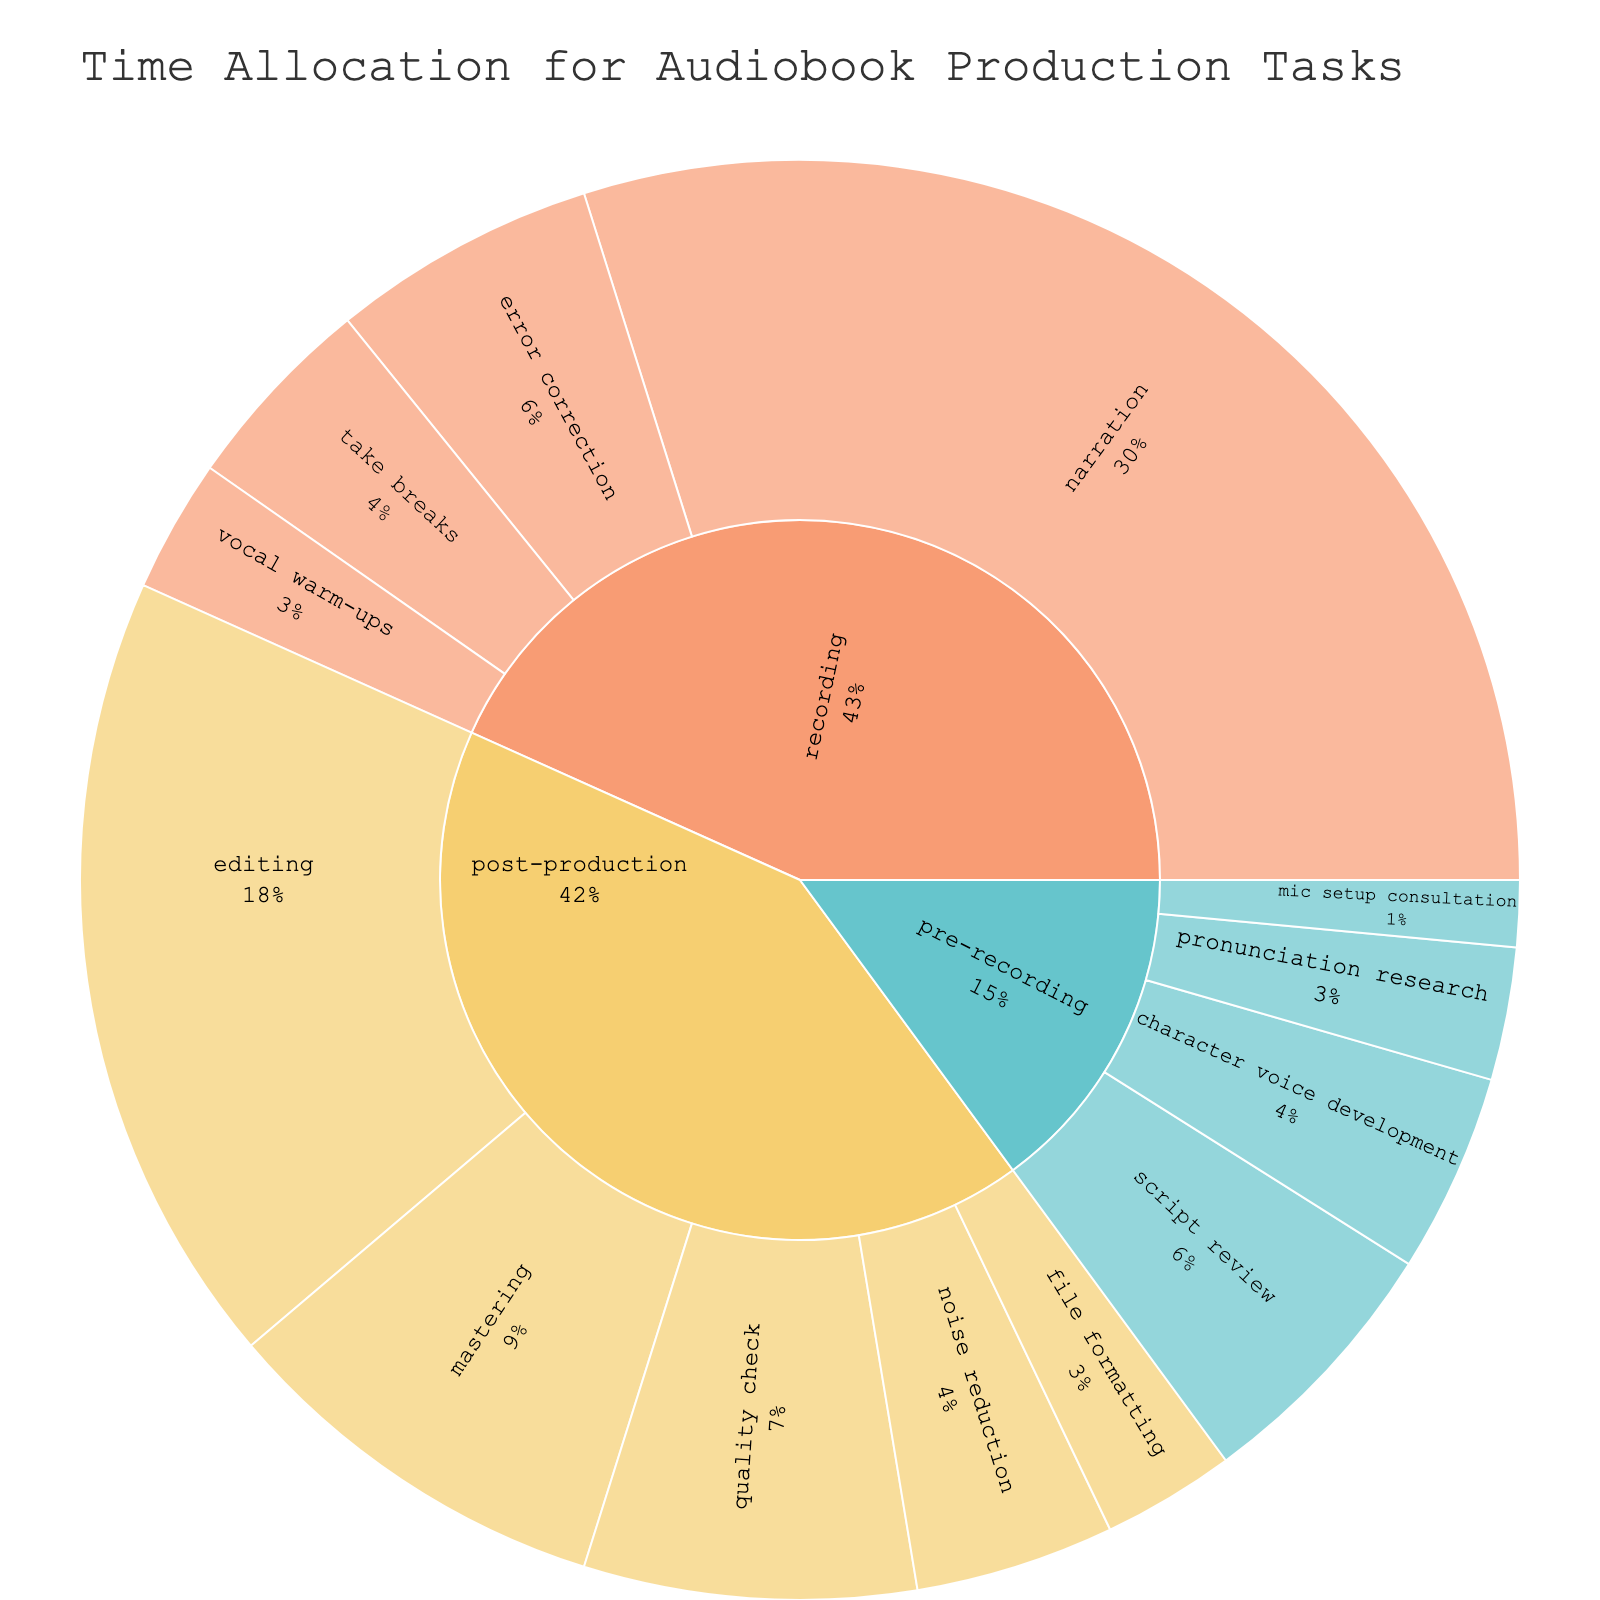What's the title of the figure? The title is usually placed at the top and gives an overview of the figure. Here, the title is "Time Allocation for Audiobook Production Tasks".
Answer: Time Allocation for Audiobook Production Tasks What color palette is used to distinguish different phases? The color palette is visually identifiable from the sunburst plot, and it uses a pastel color palette to distinguish between phases.
Answer: Pastel Which task takes the most time in the pre-recording phase? To find the task that takes the most time, navigate to the "pre-recording" segment and identify the task with the largest portion, which is "script review" with 20 hours.
Answer: script review How much time is spent on file formatting in the post-production phase? Locate the post-production segment and find the task labeled "file formatting". The plot shows it takes 10 hours.
Answer: 10 hours What percentage of time is spent on narration relative to other recording phase tasks? Identify the size of the "narration" segment in the recording phase and its percentage of the total recording phase time. Narration takes 100 hours out of the total 145 hours in the recording phase, which is approximately 68.97%.
Answer: ~68.97% Which phase has the highest total time allocation? Sum the total times per phase and compare. Recording has the highest with 145 hours (Narration 100, Take breaks 15, Vocal warm-ups 10, Error correction 20).
Answer: Recording What is the total time spent on the pre-recording and post-production phases combined? Sum the times for pre-recording (20 + 15 + 10 + 5 = 50 hours) and post-production (60 + 15 + 30 + 25 + 10 = 140 hours), totaling 190 hours.
Answer: 190 hours How does the time spent on noise reduction in post-production compare to error correction in recording? Check the sunburst segments for "noise reduction" in post-production (15 hours) and "error correction" in recording (20 hours). Error correction takes 5 more hours than noise reduction.
Answer: Error correction takes 5 more hours What percentage of the entire audiobook production process is allocated to editing? To find this, locate the editing task in post-production (60 hours) and divide it by the total time of all tasks (325 hours). Editing thusly constitutes (60/325)*100 ≈ 18.46%.
Answer: ~18.46% Which specific task within post-production consumes the second-least amount of time? Examine the tasks within post-production. "File formatting" takes 10 hours and "noise reduction" takes 15 hours. Thus "noise reduction" is the second-least time-consuming post-production task.
Answer: noise reduction 